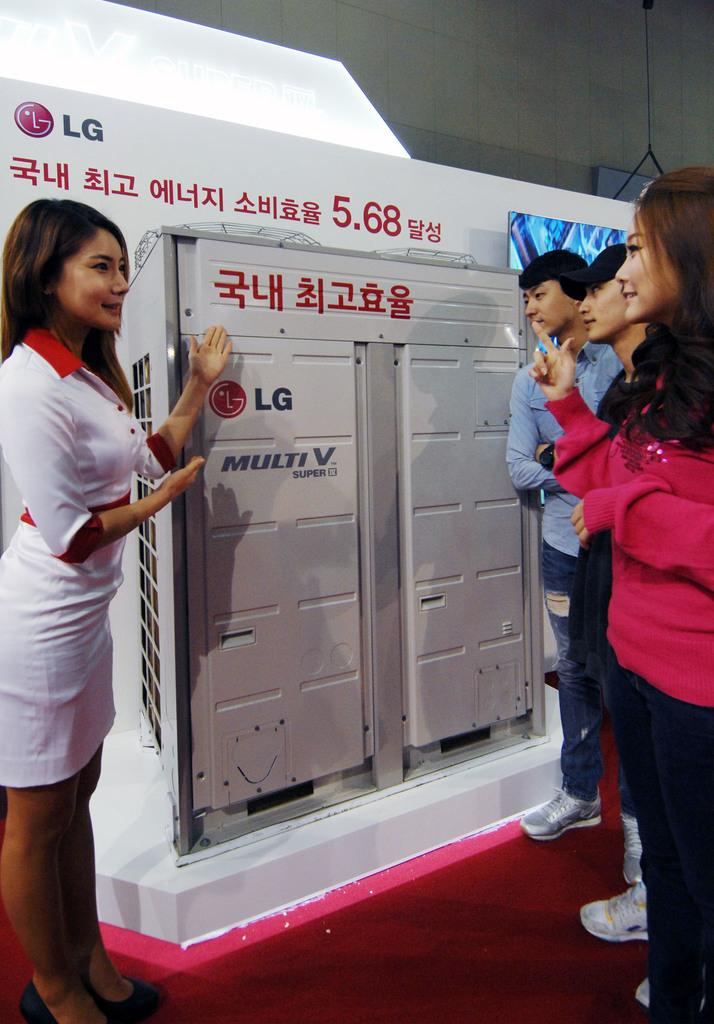<image>
Share a concise interpretation of the image provided. A woman is addressing onlookers in front of an LG Multi V display. 